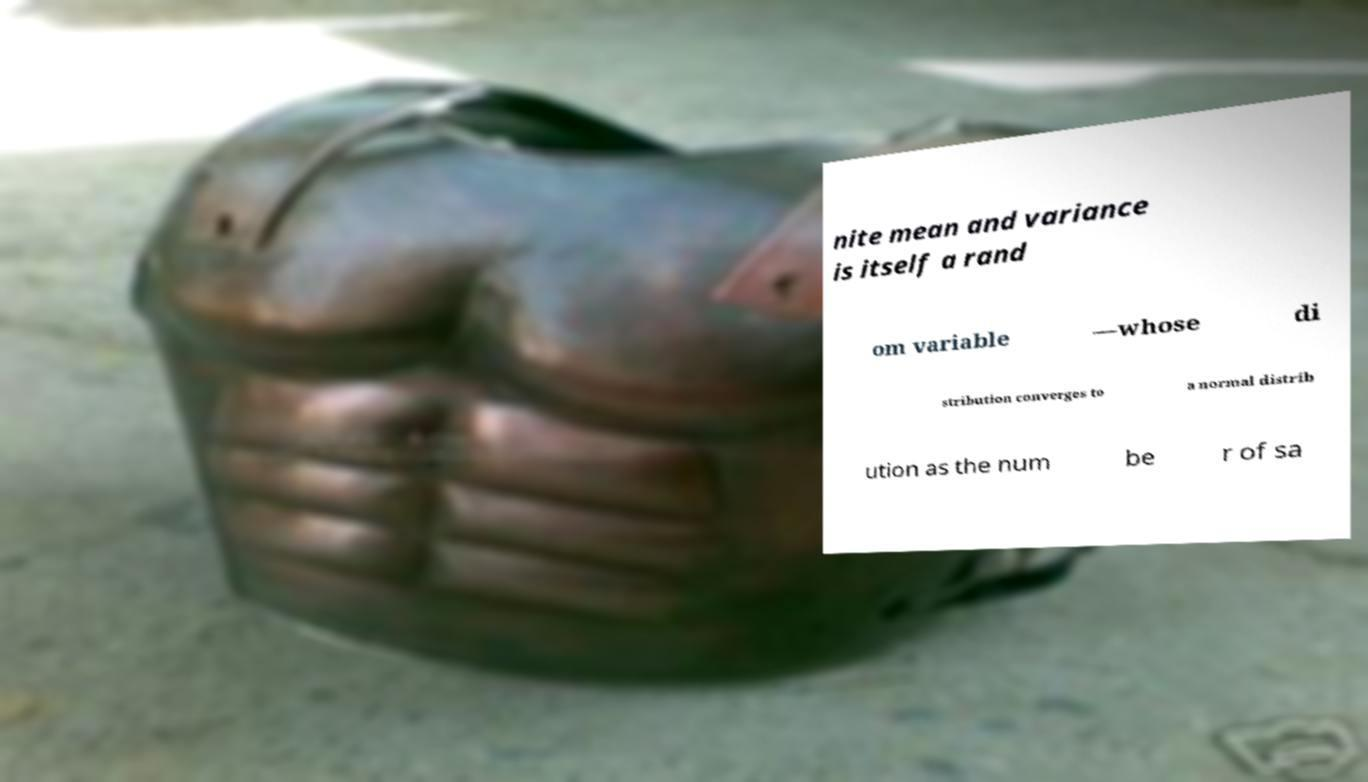Can you accurately transcribe the text from the provided image for me? nite mean and variance is itself a rand om variable —whose di stribution converges to a normal distrib ution as the num be r of sa 